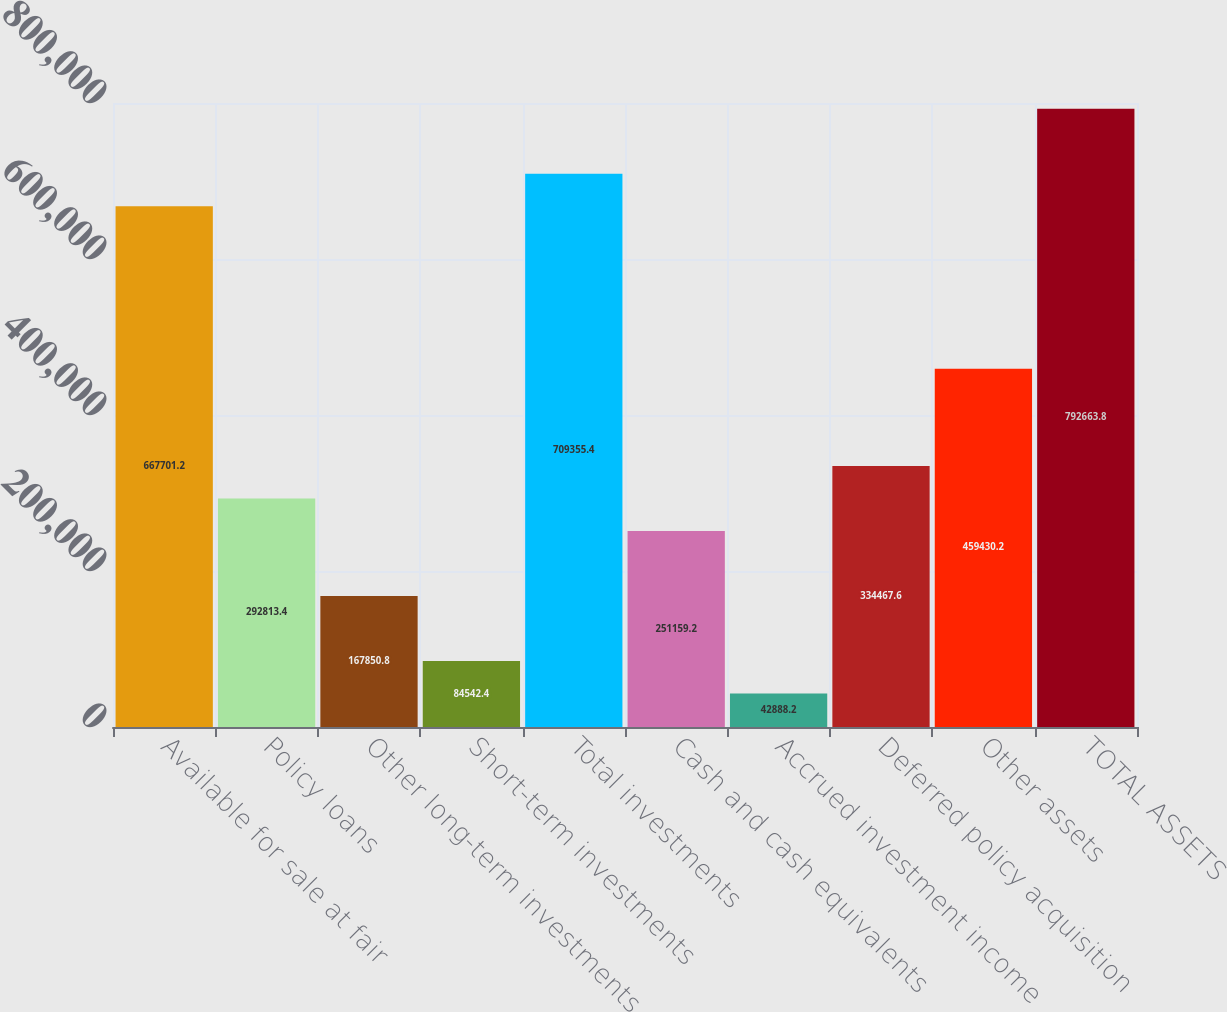Convert chart to OTSL. <chart><loc_0><loc_0><loc_500><loc_500><bar_chart><fcel>Available for sale at fair<fcel>Policy loans<fcel>Other long-term investments<fcel>Short-term investments<fcel>Total investments<fcel>Cash and cash equivalents<fcel>Accrued investment income<fcel>Deferred policy acquisition<fcel>Other assets<fcel>TOTAL ASSETS<nl><fcel>667701<fcel>292813<fcel>167851<fcel>84542.4<fcel>709355<fcel>251159<fcel>42888.2<fcel>334468<fcel>459430<fcel>792664<nl></chart> 